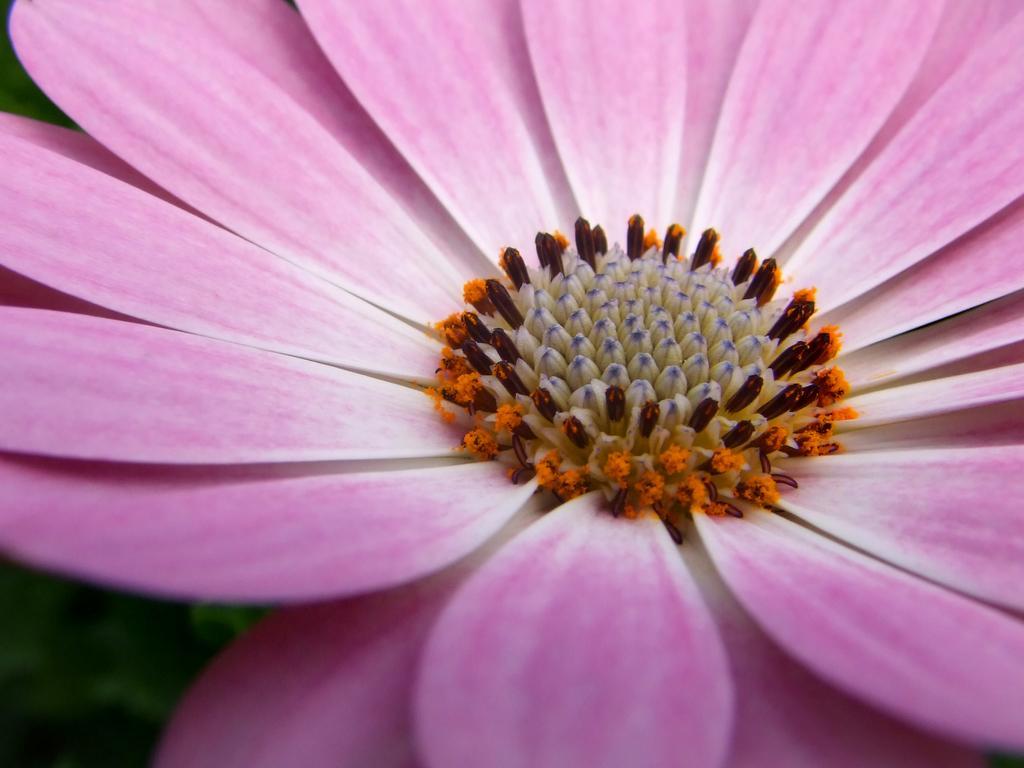Please provide a concise description of this image. In the center of the image we can see one flower, which is in multiple color. 